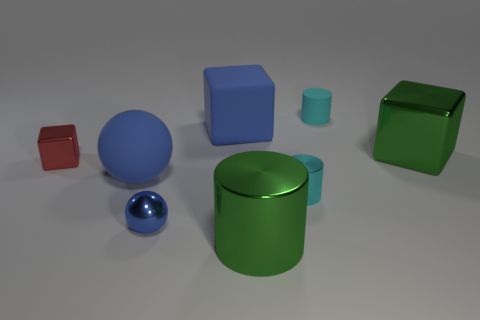Subtract all tiny metal blocks. How many blocks are left? 2 Add 1 blue spheres. How many objects exist? 9 Subtract all cyan cylinders. How many cylinders are left? 1 Subtract all yellow cubes. How many cyan cylinders are left? 2 Add 6 large metallic cubes. How many large metallic cubes are left? 7 Add 8 small cyan metal things. How many small cyan metal things exist? 9 Subtract 0 purple spheres. How many objects are left? 8 Subtract all cylinders. How many objects are left? 5 Subtract 2 blocks. How many blocks are left? 1 Subtract all red blocks. Subtract all cyan spheres. How many blocks are left? 2 